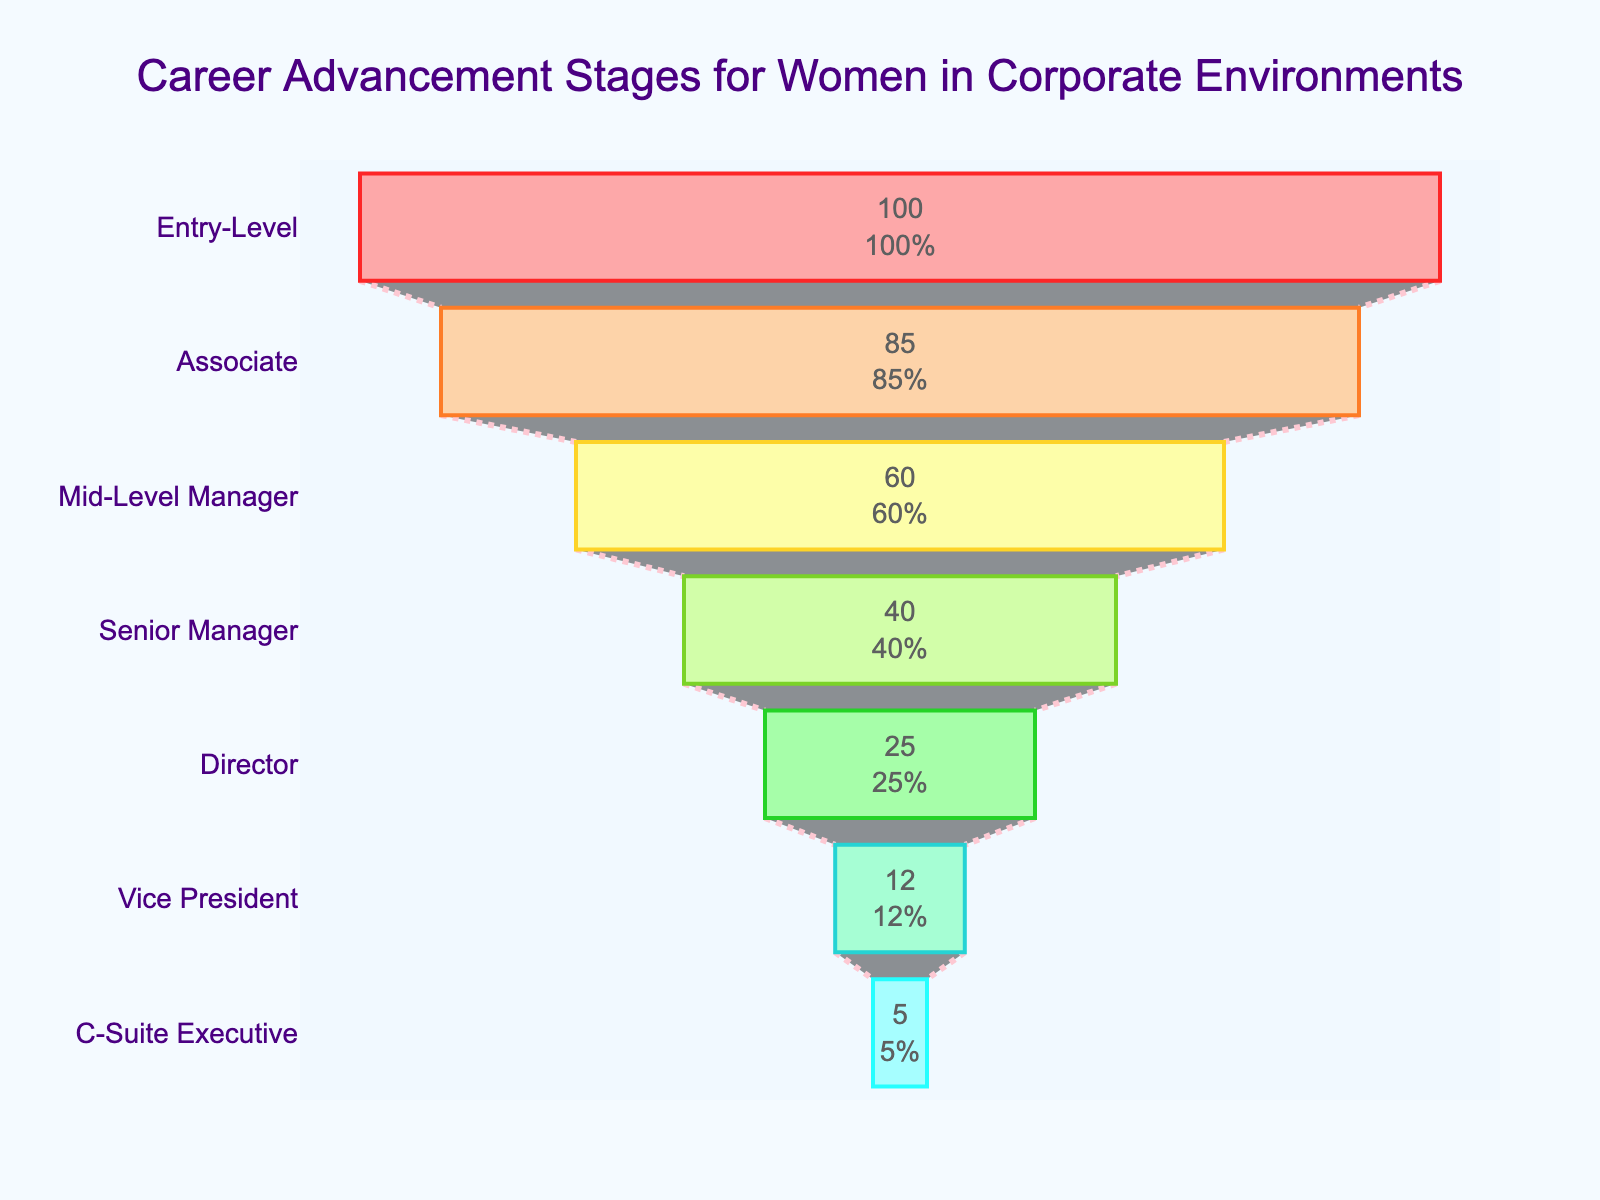What is the title of the funnel chart? The title of the funnel chart is displayed prominently at the top of the figure.
Answer: Career Advancement Stages for Women in Corporate Environments How many career stages are represented in the funnel chart? The funnel chart includes multiple segments, each representing a different career stage. Counting the segments, we find there are seven stages.
Answer: Seven What percentage of women reach the Associate level? By looking at the second segment from the top of the funnel chart, labeled 'Associate', we can see the percentage value indicated inside the segment.
Answer: 85% What is the drop in retention rate from Mid-Level Manager to Senior Manager? The percentage for Mid-Level Manager is 60%, and for Senior Manager, it is 40%. Subtract the lower percentage from the higher one: 60% - 40% = 20%.
Answer: 20% How does the retention rate change from Director to Vice President? The retention rate at the Director level is 25%, while at the Vice President level it is 12%. The change in retention rate is calculated by subtracting the lower percentage from the higher: 25% - 12% = 13%.
Answer: 13% Which career stage has the lowest retention rate? By examining the funnel chart, we can see that the stage at the bottom, labeled "C-Suite Executive," has the smallest percentage.
Answer: C-Suite Executive What percentage of women advance from an Entry-Level position to the Director level? The Entry-Level percentage is 100%, and the Director level percentage is 25%. The advancement percentage is the Director percentage, as it represents the proportion who remain from the Entry-Level.
Answer: 25% Is the retention rate higher for Mid-Level Managers or Vice Presidents? By comparing the percentages in the funnel chart, we see that Mid-Level Managers have a retention rate of 60%, while Vice Presidents have a retention rate of 12%.
Answer: Mid-Level Managers What is the cumulative drop in retention rate from Entry-Level to C-Suite Executive? Starting from 100% at Entry-Level to 5% at C-Suite Executive, the cumulative drop is calculated by subtracting the C-Suite Executive percentage from the Entry-Level percentage: 100% - 5% = 95%.
Answer: 95% Which stages see the highest and lowest declines in retention rate? The largest decline can be found by comparing adjacent stages. From Entry-Level to Associate is -15% (100% - 85%), from Associate to Mid-Level Manager is -25% (85% - 60%), from Mid-Level Manager to Senior Manager is -20% (60% - 40%), from Senior Manager to Director is -15% (40% - 25%), from Director to Vice President is -13% (25% - 12%), and from Vice President to C-Suite Executive is -7% (12% - 5%). The highest decline is from Associate to Mid-Level Manager (-25%) and the lowest from Vice President to C-Suite Executive (-7%).
Answer: Highest: Associate to Mid-Level Manager; Lowest: Vice President to C-Suite Executive 